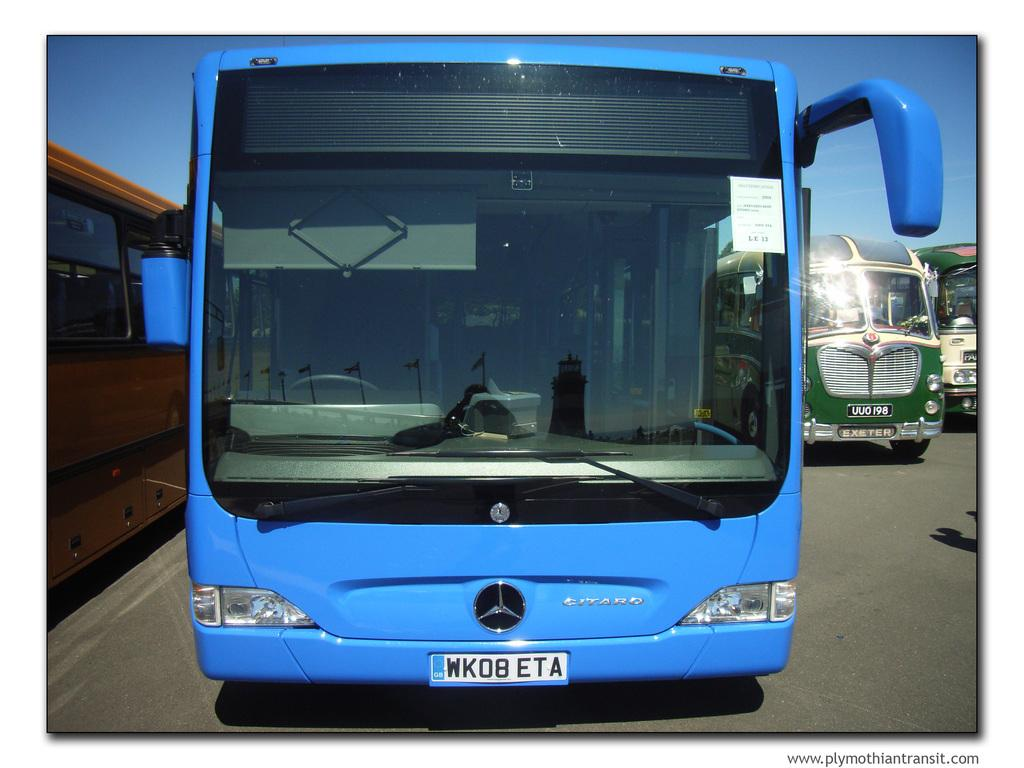<image>
Describe the image concisely. A blue bus with license plate: "MK08 ETA" 